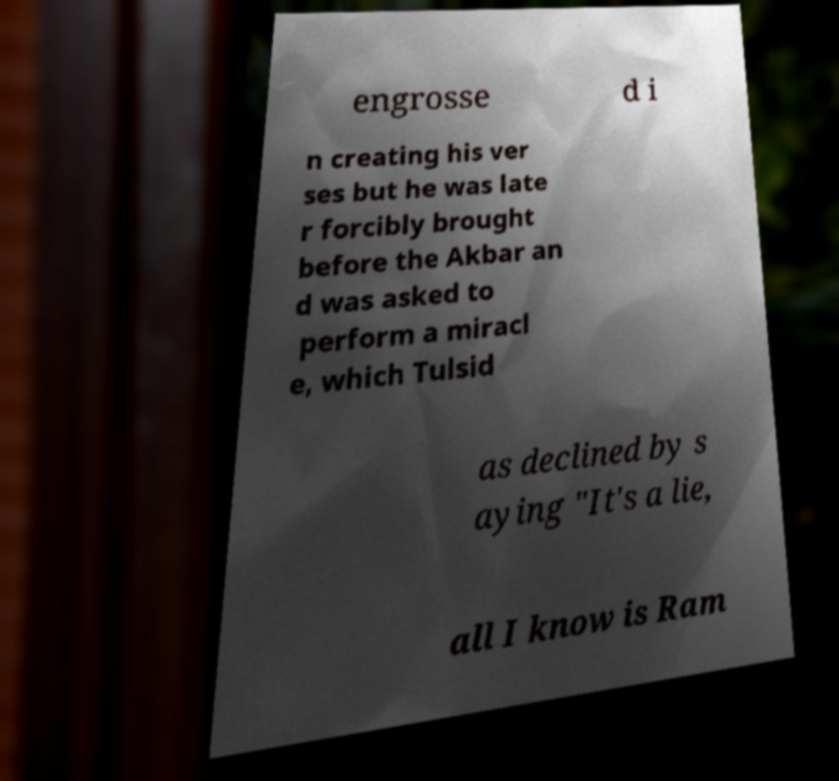Please read and relay the text visible in this image. What does it say? engrosse d i n creating his ver ses but he was late r forcibly brought before the Akbar an d was asked to perform a miracl e, which Tulsid as declined by s aying "It's a lie, all I know is Ram 